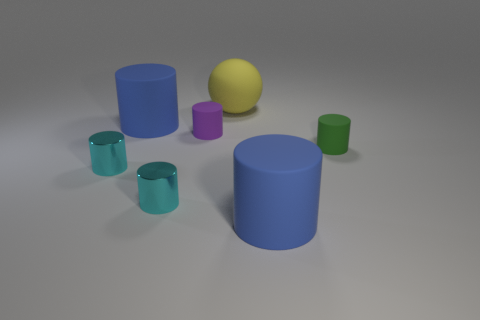There is a tiny green matte thing that is on the right side of the large blue thing that is on the left side of the big blue object that is in front of the green thing; what shape is it?
Offer a very short reply. Cylinder. How many things are either small cylinders to the left of the green cylinder or large rubber objects?
Your answer should be compact. 6. How many objects are either yellow things or big matte objects that are on the right side of the yellow thing?
Make the answer very short. 2. How many cyan objects are the same size as the rubber sphere?
Your answer should be very brief. 0. Is the number of tiny cylinders that are on the right side of the sphere less than the number of small green cylinders left of the small purple cylinder?
Your response must be concise. No. What number of matte things are small purple things or green cylinders?
Your answer should be compact. 2. The green matte object is what shape?
Your answer should be compact. Cylinder. What material is the green cylinder that is the same size as the purple object?
Offer a very short reply. Rubber. How many big things are yellow objects or purple things?
Make the answer very short. 1. Is there a big blue matte thing?
Ensure brevity in your answer.  Yes. 